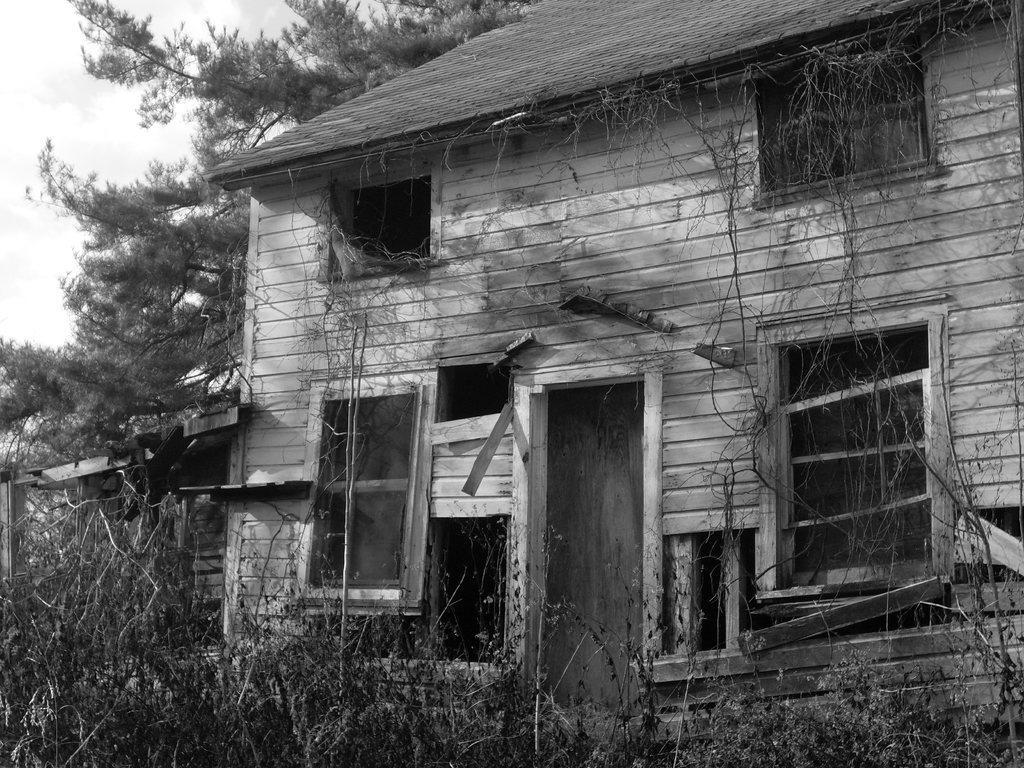Can you describe this image briefly? In this image I can see a house and I can see windows and at the bottom I can see grass and at the top I can see the sky and tree. 